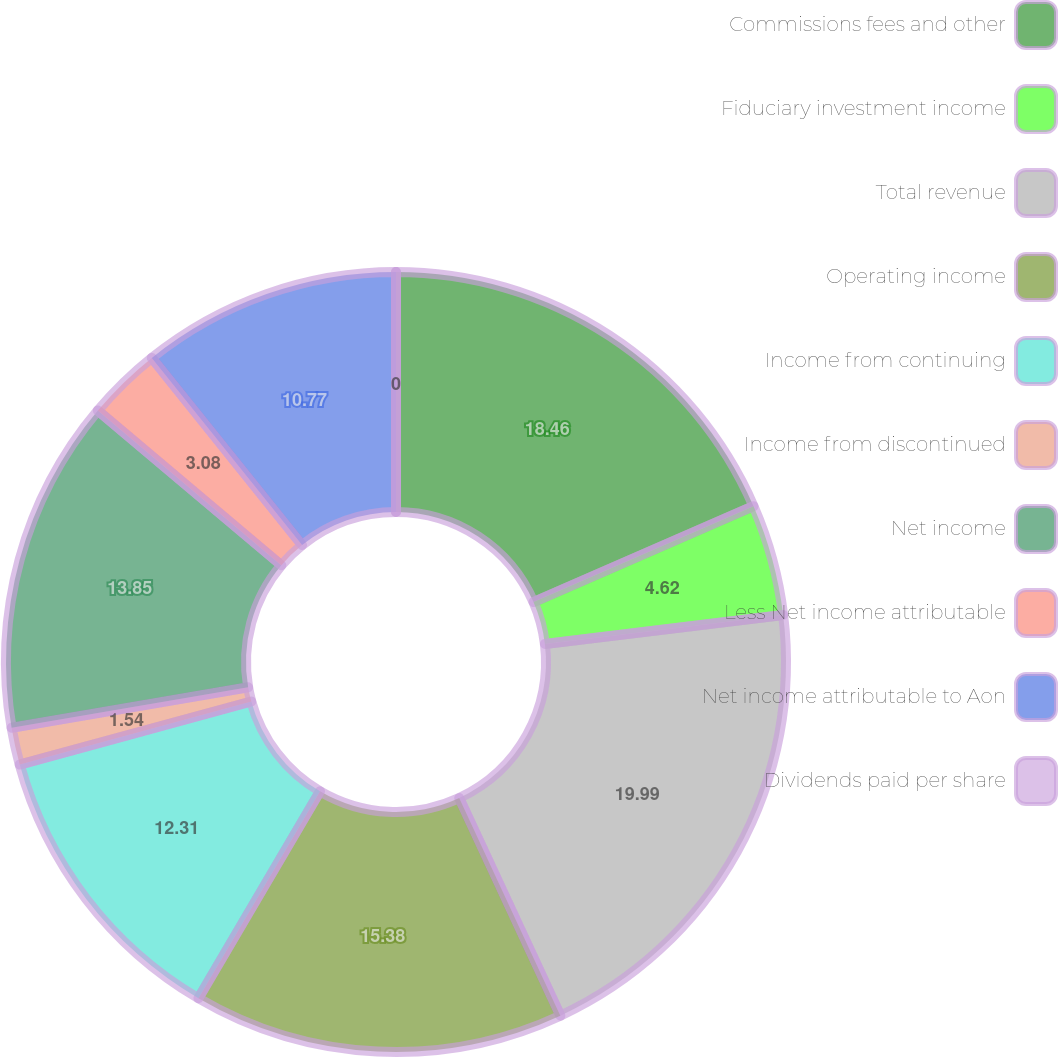<chart> <loc_0><loc_0><loc_500><loc_500><pie_chart><fcel>Commissions fees and other<fcel>Fiduciary investment income<fcel>Total revenue<fcel>Operating income<fcel>Income from continuing<fcel>Income from discontinued<fcel>Net income<fcel>Less Net income attributable<fcel>Net income attributable to Aon<fcel>Dividends paid per share<nl><fcel>18.46%<fcel>4.62%<fcel>20.0%<fcel>15.38%<fcel>12.31%<fcel>1.54%<fcel>13.85%<fcel>3.08%<fcel>10.77%<fcel>0.0%<nl></chart> 